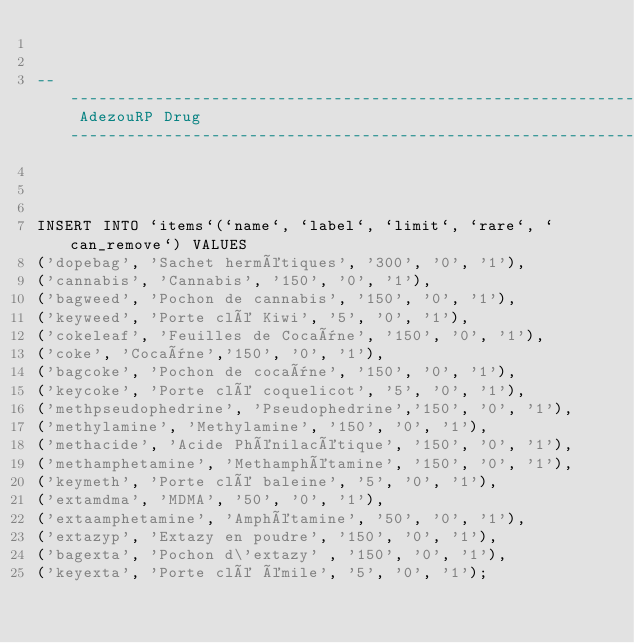Convert code to text. <code><loc_0><loc_0><loc_500><loc_500><_SQL_>

---------------------------------------------------------------------------------------------- AdezouRP Drug ---------------------------------------------------------------------------------------------------



INSERT INTO `items`(`name`, `label`, `limit`, `rare`, `can_remove`) VALUES
('dopebag', 'Sachet hermétiques', '300', '0', '1'),
('cannabis', 'Cannabis', '150', '0', '1'),
('bagweed', 'Pochon de cannabis', '150', '0', '1'),
('keyweed', 'Porte clé Kiwi', '5', '0', '1'),
('cokeleaf', 'Feuilles de Cocaïne', '150', '0', '1'),
('coke', 'Cocaïne','150', '0', '1'),
('bagcoke', 'Pochon de cocaïne', '150', '0', '1'),
('keycoke', 'Porte clé coquelicot', '5', '0', '1'),
('methpseudophedrine', 'Pseudophedrine','150', '0', '1'),
('methylamine', 'Methylamine', '150', '0', '1'),
('methacide', 'Acide Phénilacétique', '150', '0', '1'),
('methamphetamine', 'Methamphétamine', '150', '0', '1'),
('keymeth', 'Porte clé baleine', '5', '0', '1'),
('extamdma', 'MDMA', '50', '0', '1'),
('extaamphetamine', 'Amphétamine', '50', '0', '1'),
('extazyp', 'Extazy en poudre', '150', '0', '1'),
('bagexta', 'Pochon d\'extazy' , '150', '0', '1'),
('keyexta', 'Porte clé émile', '5', '0', '1');

</code> 